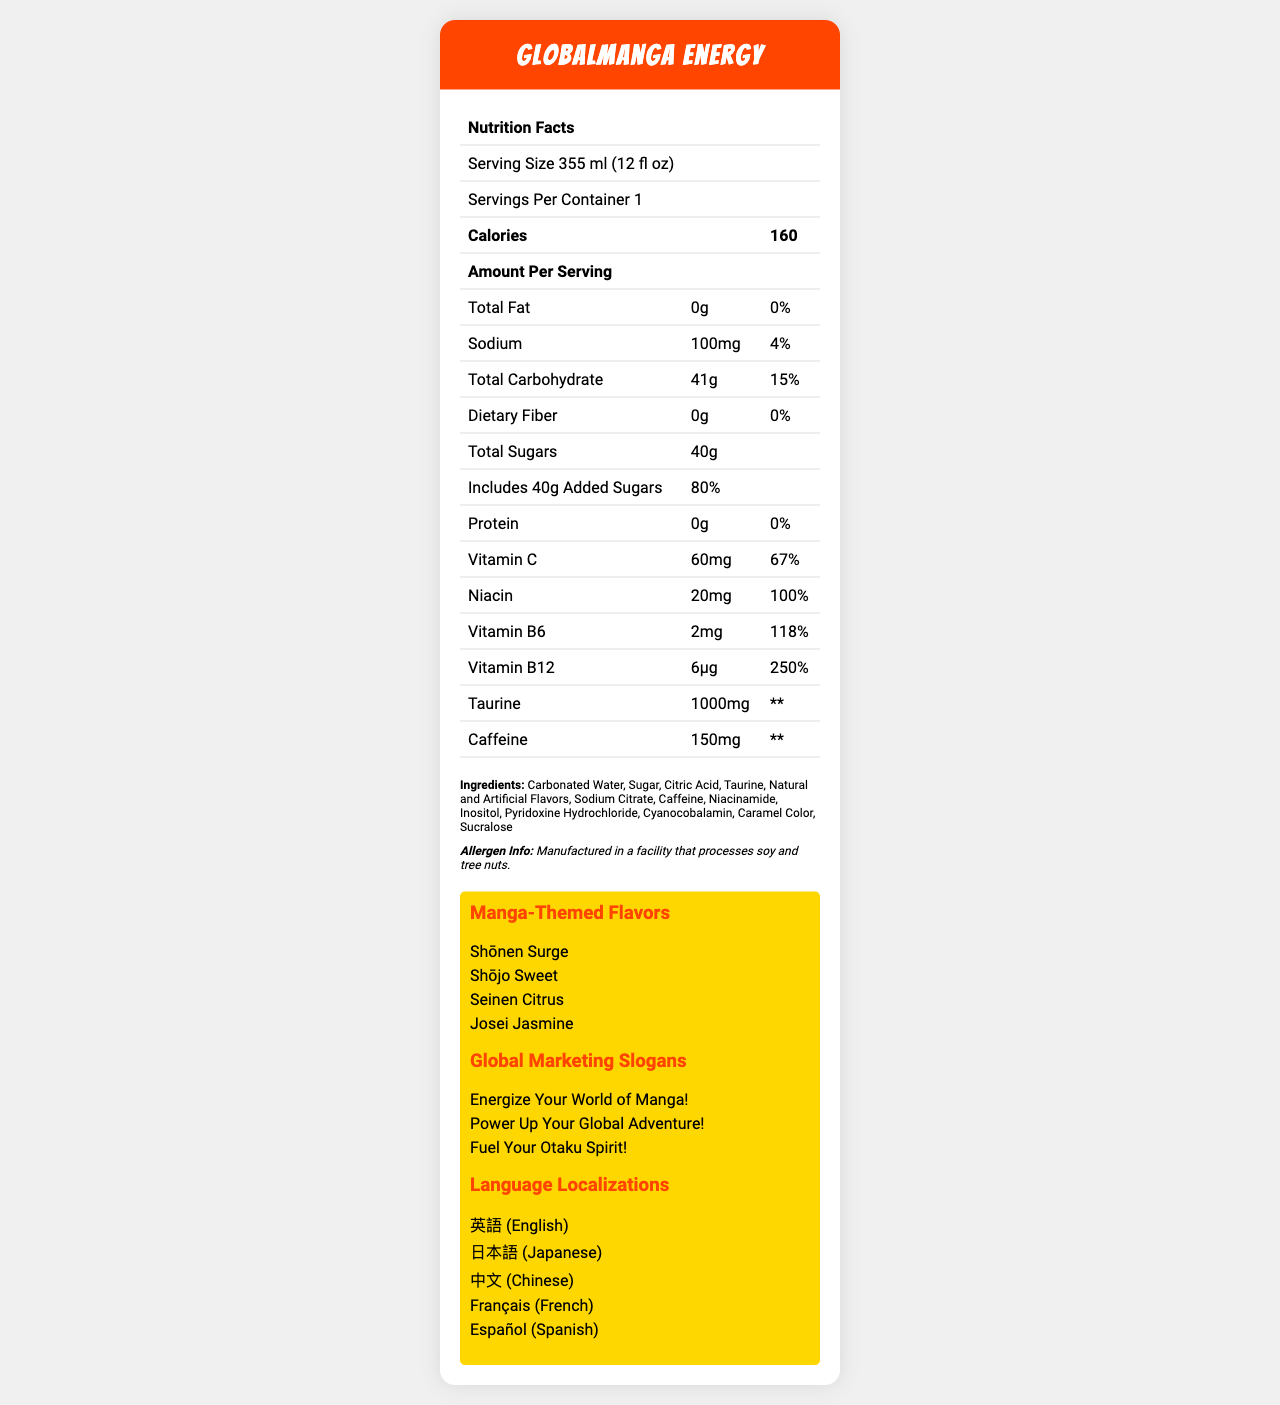What is the serving size for Globalmanga Energy? The serving size is explicitly stated on the document as "355 ml (12 fl oz)".
Answer: 355 ml (12 fl oz) How many calories are there per serving? The number of calories per serving is listed as 160 in the document.
Answer: 160 Does the product contain any dietary fiber? The document mentions that dietary fiber is 0g with a daily value of 0%.
Answer: No What is the daily value percentage for Vitamin C? The daily value percentage for Vitamin C is shown as 67% in the document.
Answer: 67% Which manga artists collaborated on Globalmanga Energy? The document lists these three manga artists as collaborators.
Answer: Eiichiro Oda (One Piece), Naoko Takeuchi (Sailor Moon), Hajime Isayama (Attack on Titan) What are the manga-themed flavors available? These four flavors are specified under the "Manga-Themed Flavors" section.
Answer: Shōnen Surge, Shōjo Sweet, Seinen Citrus, Josei Jasmine What is the daily value percentage for the total carbohydrates per serving? The document indicates that the total carbohydrate daily value percentage is 15%.
Answer: 15% List the global marketing slogans used for Globalmanga Energy. The document lists these three global marketing slogans.
Answer: Energize Your World of Manga!, Power Up Your Global Adventure!, Fuel Your Otaku Spirit! Does the product contain any protein? The document states that the protein amount is 0g with a daily value of 0%.
Answer: No What ingredient is listed immediately after "Sugar"? The document lists Citric Acid immediately following Sugar in the ingredients section.
Answer: Citric Acid Select the correct amount of caffeine included in the drink:
A. 50mg
B. 100mg
C. 150mg
D. 200mg The document specifies that the amount of caffeine is 150mg.
Answer: C. 150mg What is the implied daily value for taurine and caffeine marked on the document? 
1. 4%
2. 67%
3. ** (Not Determined)
4. 80% The document shows asterisks (**) indicating that the daily value for taurine and caffeine is not determined.
Answer: 3. ** (Not Determined) Is "Carbonated Water" one of the ingredients? The document lists "Carbonated Water" as the first ingredient.
Answer: Yes Summarize the main characteristics of the "Globalmanga Energy" drink as presented in the document. This summary encapsulates the drink's nutritional information, marketing strategy, and cultural elements as detailed in the document.
Answer: "Globalmanga Energy" is a manga-themed energy drink with 160 calories per 355 ml serving, featuring a variety of flavors inspired by different manga genres. It includes essential vitamins such as Vitamin C, Niacin, B6, and B12, along with taurine and caffeine. The drink has a high sugar content with 40g of total sugars. Marketing highlights include multicultural slogans, international language localizations, and collaborations with popular manga artists. The ingredients list includes carbonated water, sugar, and other common additives, and the product is manufactured in a facility that processes soy and tree nuts. What is the percentage daily value of added sugars in "Globalmanga Energy"? The document states that the added sugars contribute 80% to the daily value.
Answer: 80% How many languages is the product localized in? The document lists five languages for localization: English, Japanese, Chinese, French, and Spanish.
Answer: 5 How much Vitamin B12 is included in each serving? The document specifies that Vitamin B12 amount is 6μg per serving.
Answer: 6μg What cultural fusion elements are incorporated in Globalmanga Energy's design? The document lists these three cultural fusion elements.
Answer: Anime-inspired can design, QR code linking to exclusive manga content, Collectible character stickers with each purchase Where is Globalmanga Energy manufactured? The document does not provide any information regarding the manufacturing location except that it is produced in a facility that processes soy and tree nuts.
Answer: Cannot be determined 